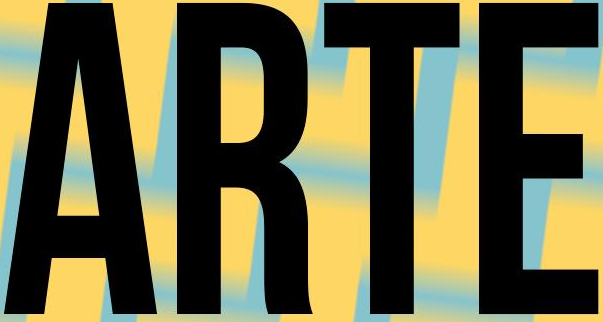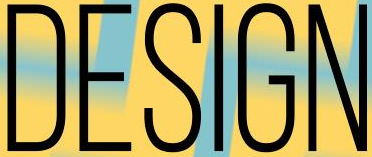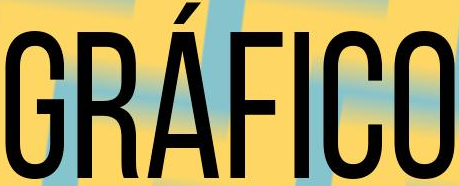Read the text from these images in sequence, separated by a semicolon. ARTE; DESIGN; GRÁFICO 